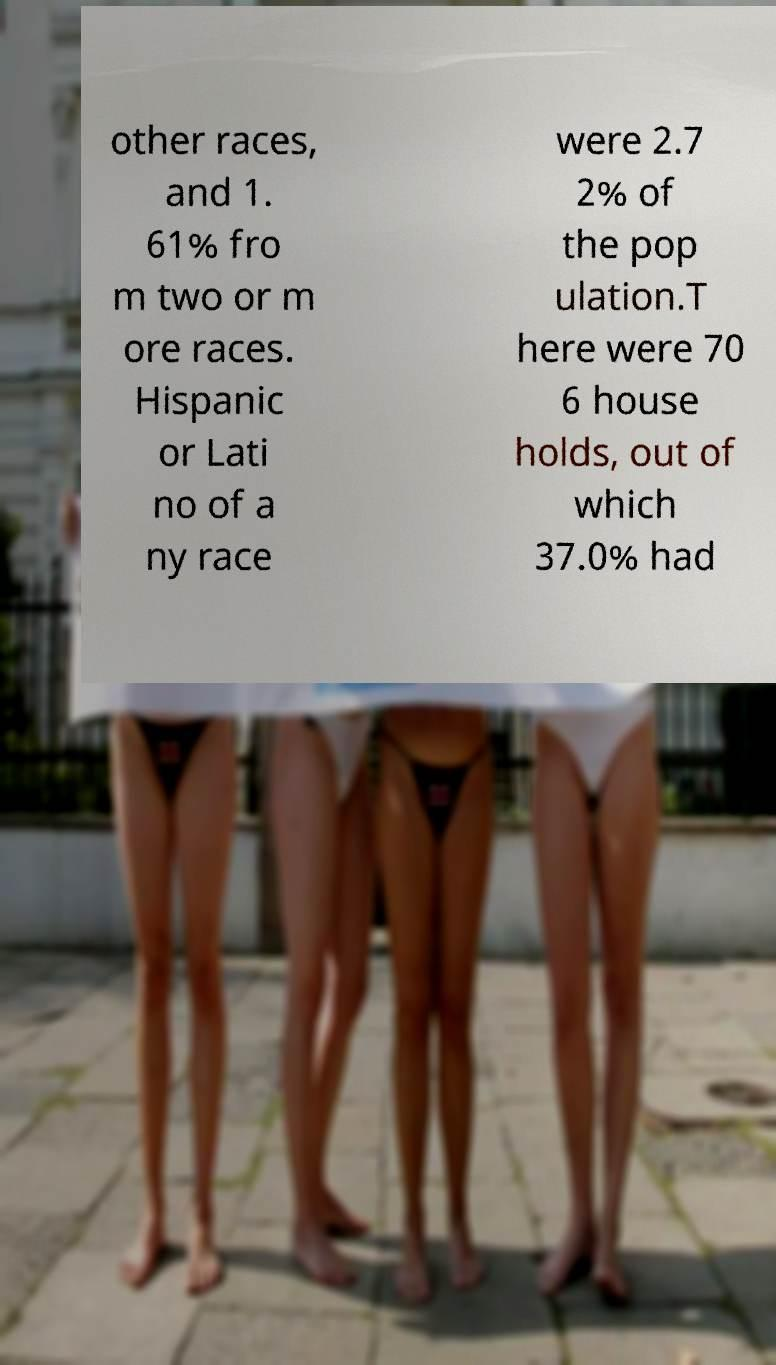Please read and relay the text visible in this image. What does it say? other races, and 1. 61% fro m two or m ore races. Hispanic or Lati no of a ny race were 2.7 2% of the pop ulation.T here were 70 6 house holds, out of which 37.0% had 